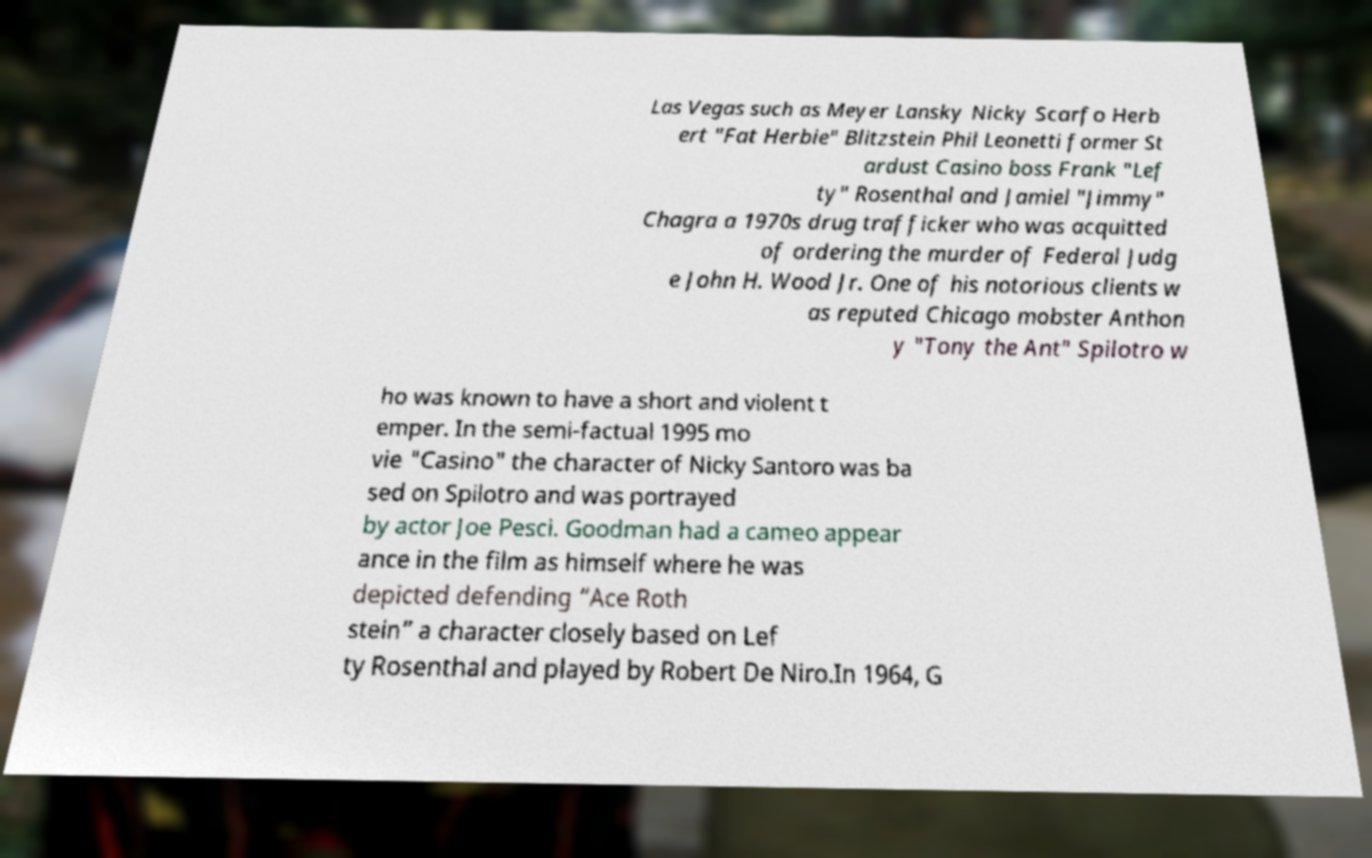Can you accurately transcribe the text from the provided image for me? Las Vegas such as Meyer Lansky Nicky Scarfo Herb ert "Fat Herbie" Blitzstein Phil Leonetti former St ardust Casino boss Frank "Lef ty" Rosenthal and Jamiel "Jimmy" Chagra a 1970s drug trafficker who was acquitted of ordering the murder of Federal Judg e John H. Wood Jr. One of his notorious clients w as reputed Chicago mobster Anthon y "Tony the Ant" Spilotro w ho was known to have a short and violent t emper. In the semi-factual 1995 mo vie "Casino" the character of Nicky Santoro was ba sed on Spilotro and was portrayed by actor Joe Pesci. Goodman had a cameo appear ance in the film as himself where he was depicted defending “Ace Roth stein” a character closely based on Lef ty Rosenthal and played by Robert De Niro.In 1964, G 